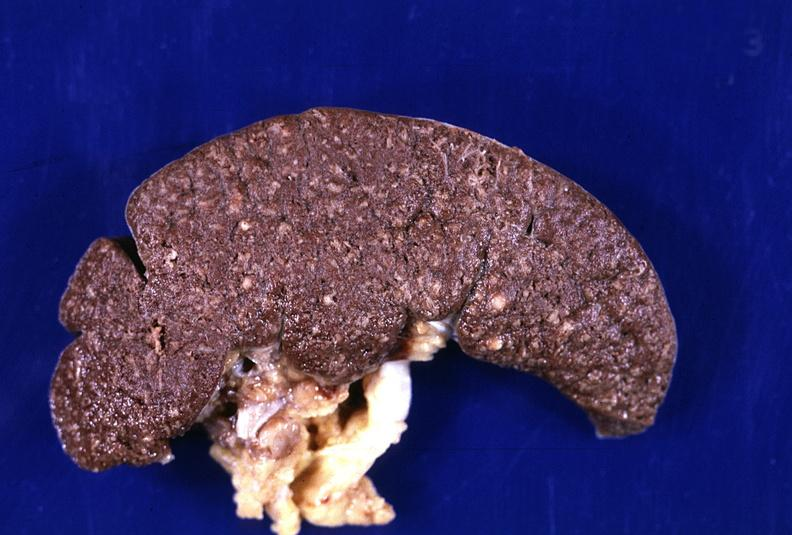what is present?
Answer the question using a single word or phrase. Hematologic 